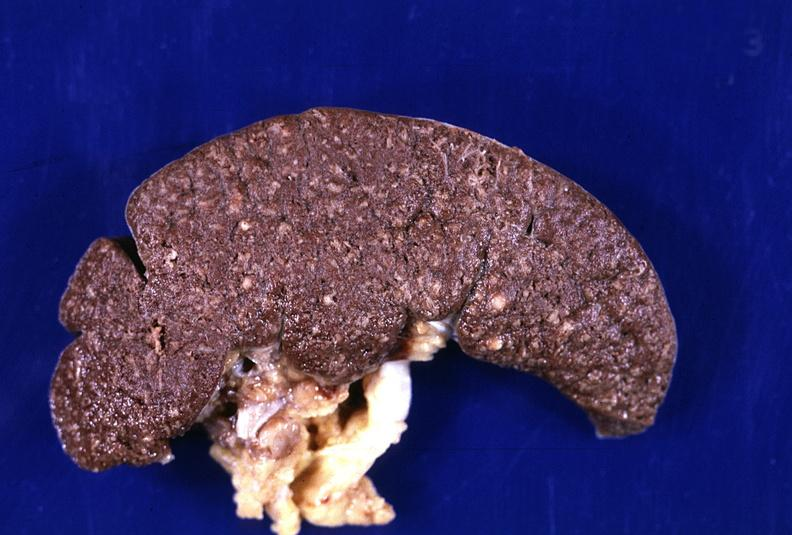what is present?
Answer the question using a single word or phrase. Hematologic 